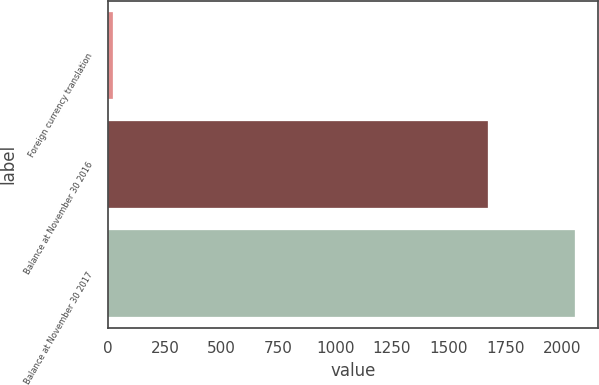Convert chart to OTSL. <chart><loc_0><loc_0><loc_500><loc_500><bar_chart><fcel>Foreign currency translation<fcel>Balance at November 30 2016<fcel>Balance at November 30 2017<nl><fcel>23.9<fcel>1671.1<fcel>2055.6<nl></chart> 